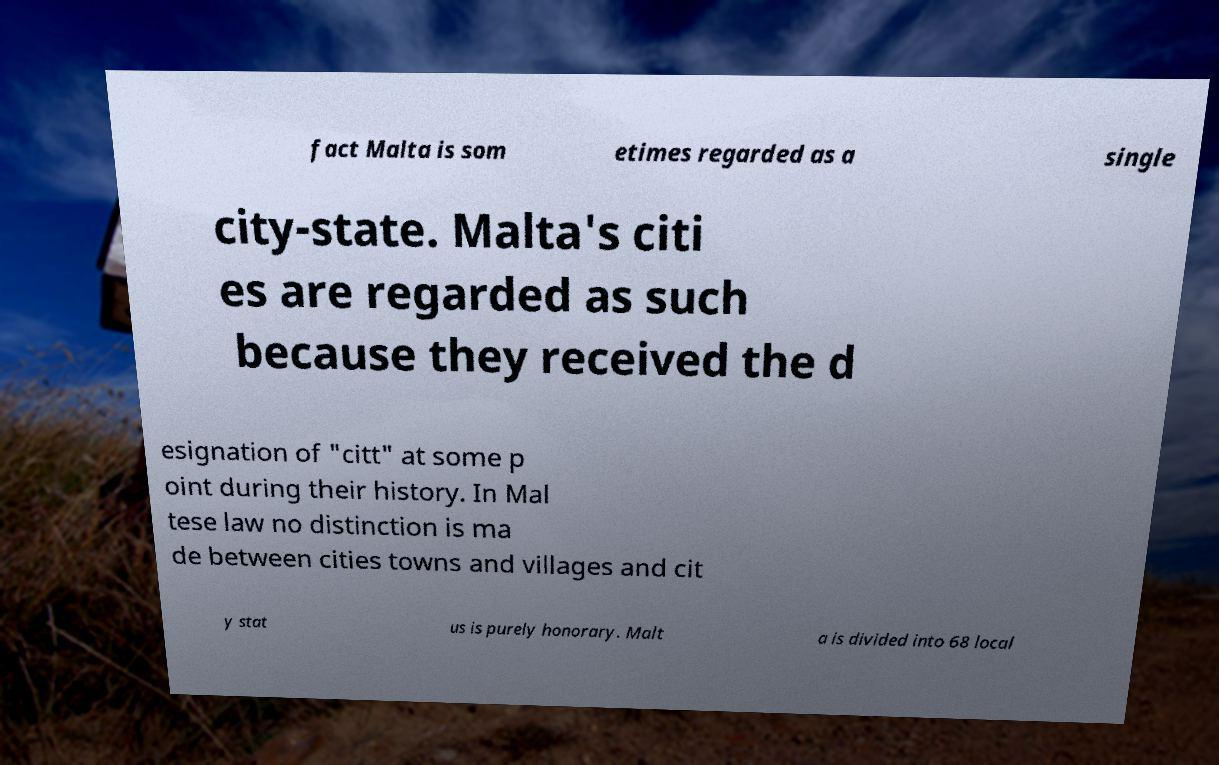What messages or text are displayed in this image? I need them in a readable, typed format. fact Malta is som etimes regarded as a single city-state. Malta's citi es are regarded as such because they received the d esignation of "citt" at some p oint during their history. In Mal tese law no distinction is ma de between cities towns and villages and cit y stat us is purely honorary. Malt a is divided into 68 local 